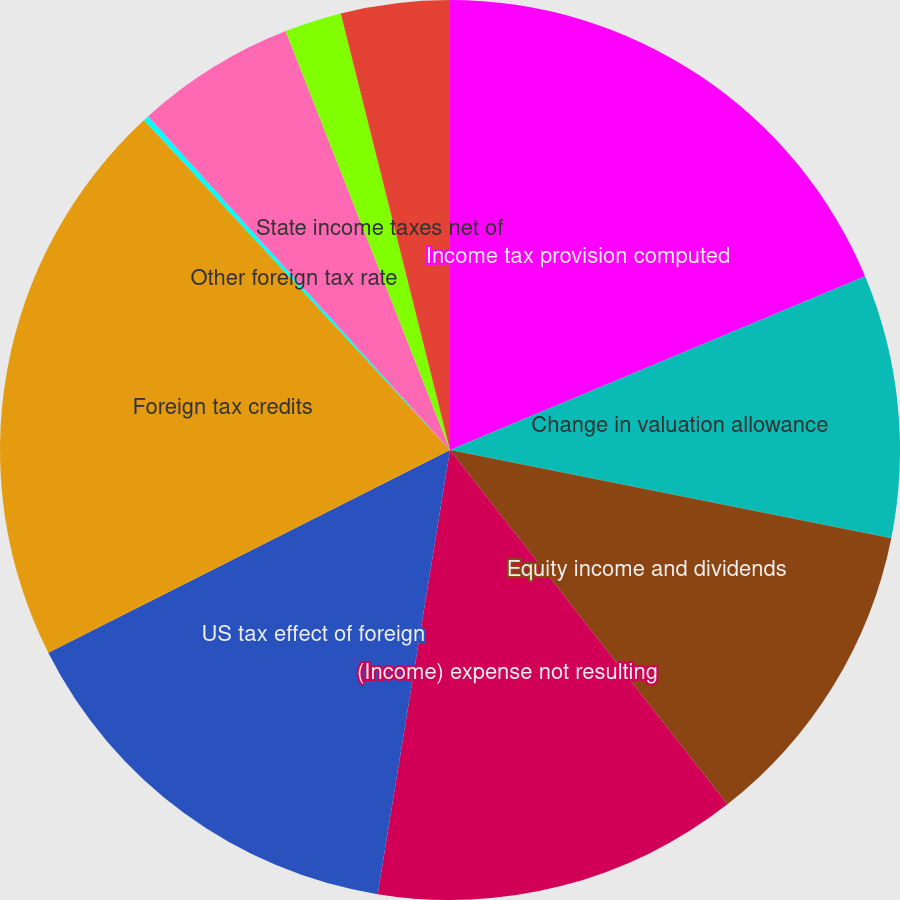<chart> <loc_0><loc_0><loc_500><loc_500><pie_chart><fcel>Income tax provision computed<fcel>Change in valuation allowance<fcel>Equity income and dividends<fcel>(Income) expense not resulting<fcel>US tax effect of foreign<fcel>Foreign tax credits<fcel>Other foreign tax rate<fcel>Tax-deductible interest on<fcel>State income taxes net of<fcel>Other net<nl><fcel>18.69%<fcel>9.45%<fcel>11.29%<fcel>13.14%<fcel>14.99%<fcel>20.54%<fcel>0.2%<fcel>5.75%<fcel>2.05%<fcel>3.9%<nl></chart> 